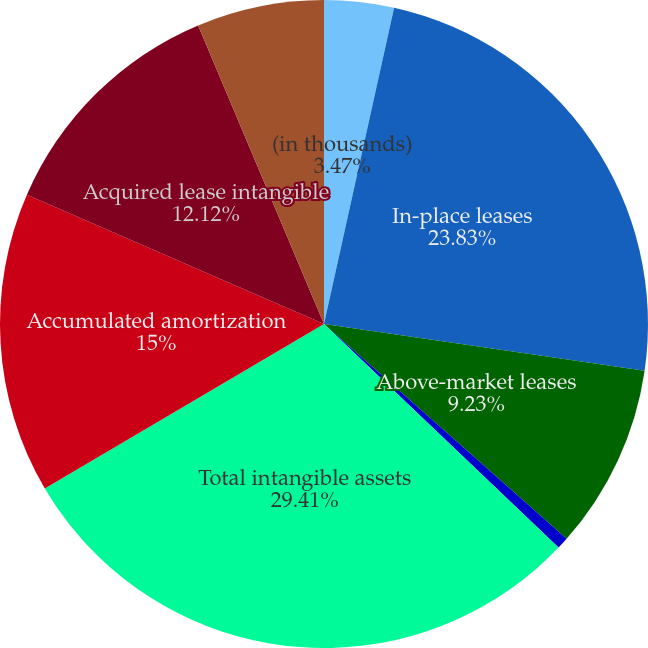<chart> <loc_0><loc_0><loc_500><loc_500><pie_chart><fcel>(in thousands)<fcel>In-place leases<fcel>Above-market leases<fcel>Below-market ground leases<fcel>Total intangible assets<fcel>Accumulated amortization<fcel>Acquired lease intangible<fcel>Accumulated accretion<nl><fcel>3.47%<fcel>23.83%<fcel>9.23%<fcel>0.59%<fcel>29.41%<fcel>15.0%<fcel>12.12%<fcel>6.35%<nl></chart> 